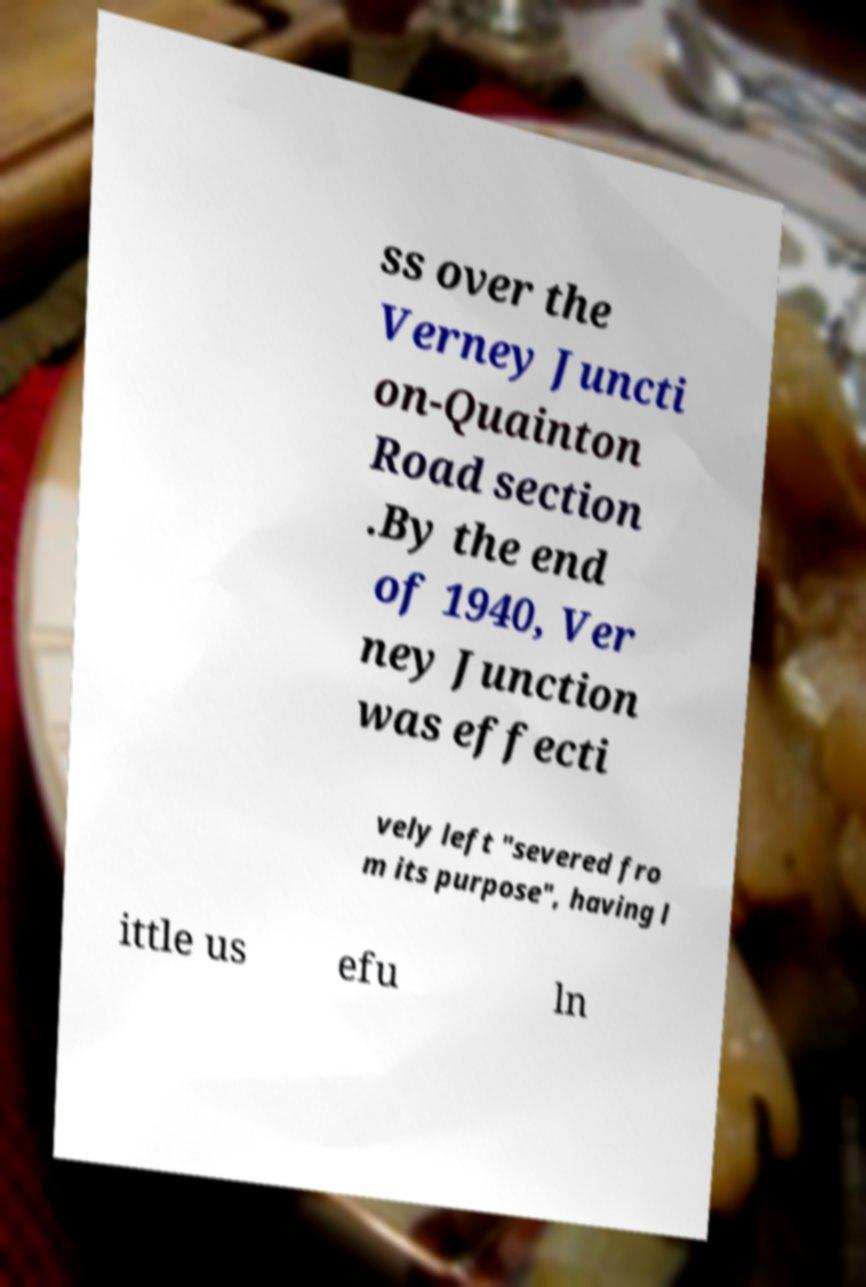What messages or text are displayed in this image? I need them in a readable, typed format. ss over the Verney Juncti on-Quainton Road section .By the end of 1940, Ver ney Junction was effecti vely left "severed fro m its purpose", having l ittle us efu ln 